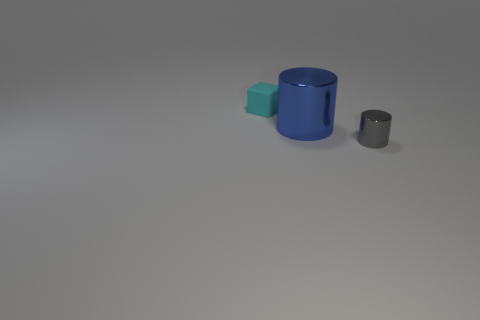Are there any tiny gray objects that have the same shape as the blue metal thing?
Ensure brevity in your answer.  Yes. The blue metallic thing has what shape?
Offer a terse response. Cylinder. Is the number of tiny matte blocks left of the small gray metal cylinder greater than the number of tiny cyan cubes in front of the blue metallic cylinder?
Your response must be concise. Yes. What number of other things are there of the same size as the cube?
Keep it short and to the point. 1. There is a thing that is behind the small gray cylinder and in front of the cyan rubber object; what material is it?
Keep it short and to the point. Metal. There is a cylinder behind the tiny object right of the tiny cyan block; what number of cylinders are left of it?
Make the answer very short. 0. Is there anything else that is the same color as the rubber block?
Your answer should be very brief. No. What number of small things are both in front of the tiny cyan matte object and behind the blue metallic thing?
Make the answer very short. 0. There is a gray object to the right of the big shiny cylinder; is its size the same as the cylinder behind the small shiny thing?
Offer a very short reply. No. What number of objects are either small objects that are in front of the cyan thing or small gray things?
Your answer should be very brief. 1. 